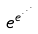<formula> <loc_0><loc_0><loc_500><loc_500>e ^ { e ^ { \cdot ^ { \cdot ^ { \cdot } } } }</formula> 